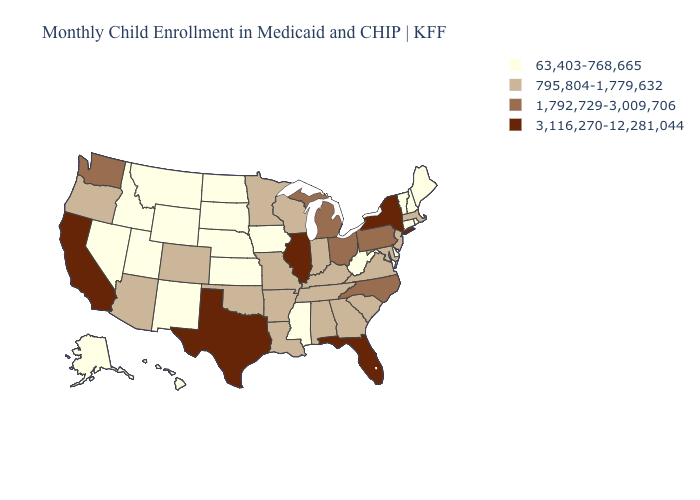Does Wisconsin have a lower value than California?
Quick response, please. Yes. What is the highest value in the USA?
Concise answer only. 3,116,270-12,281,044. Does Montana have the same value as Washington?
Give a very brief answer. No. What is the lowest value in the USA?
Give a very brief answer. 63,403-768,665. Among the states that border Georgia , which have the lowest value?
Give a very brief answer. Alabama, South Carolina, Tennessee. Name the states that have a value in the range 1,792,729-3,009,706?
Quick response, please. Michigan, North Carolina, Ohio, Pennsylvania, Washington. Name the states that have a value in the range 3,116,270-12,281,044?
Keep it brief. California, Florida, Illinois, New York, Texas. Does Rhode Island have the lowest value in the Northeast?
Concise answer only. Yes. Does Minnesota have the lowest value in the USA?
Be succinct. No. What is the highest value in the Northeast ?
Give a very brief answer. 3,116,270-12,281,044. Name the states that have a value in the range 1,792,729-3,009,706?
Be succinct. Michigan, North Carolina, Ohio, Pennsylvania, Washington. Name the states that have a value in the range 1,792,729-3,009,706?
Quick response, please. Michigan, North Carolina, Ohio, Pennsylvania, Washington. Name the states that have a value in the range 3,116,270-12,281,044?
Answer briefly. California, Florida, Illinois, New York, Texas. Does Missouri have the same value as Alabama?
Write a very short answer. Yes. What is the value of California?
Give a very brief answer. 3,116,270-12,281,044. 